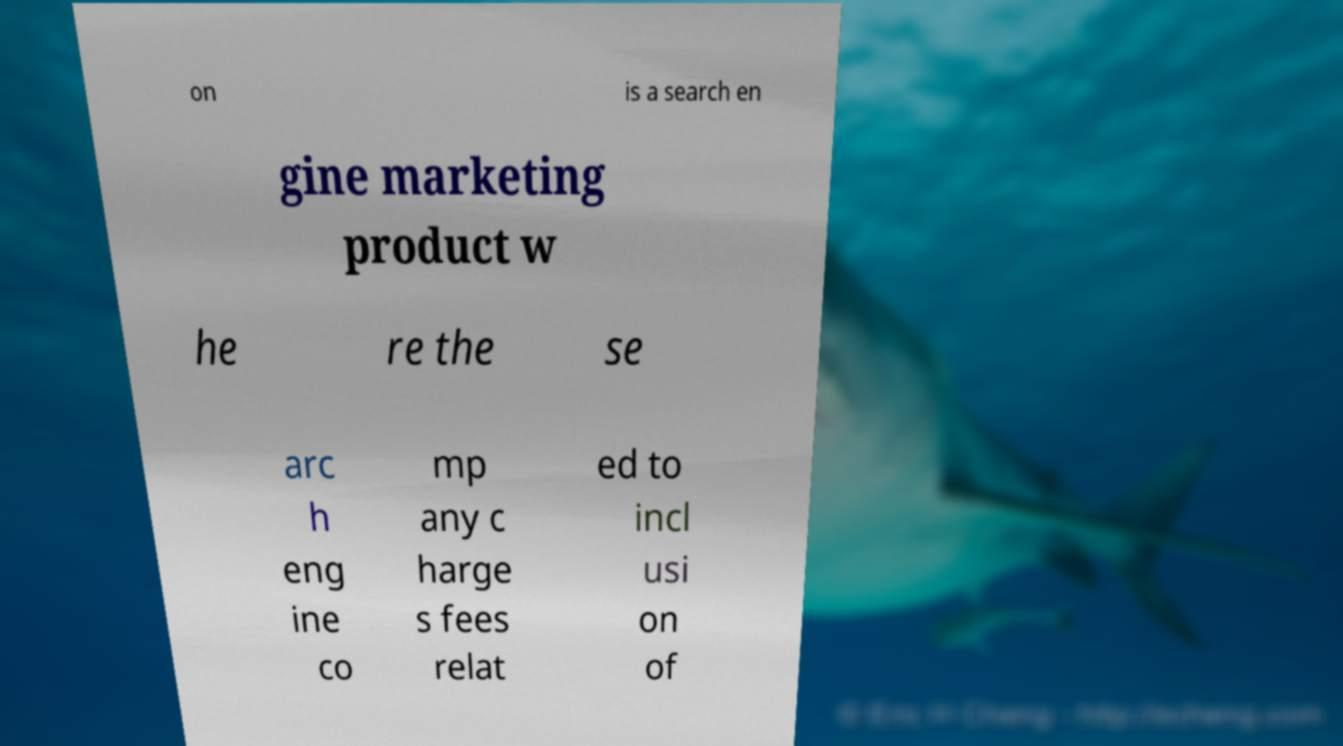Can you accurately transcribe the text from the provided image for me? on is a search en gine marketing product w he re the se arc h eng ine co mp any c harge s fees relat ed to incl usi on of 